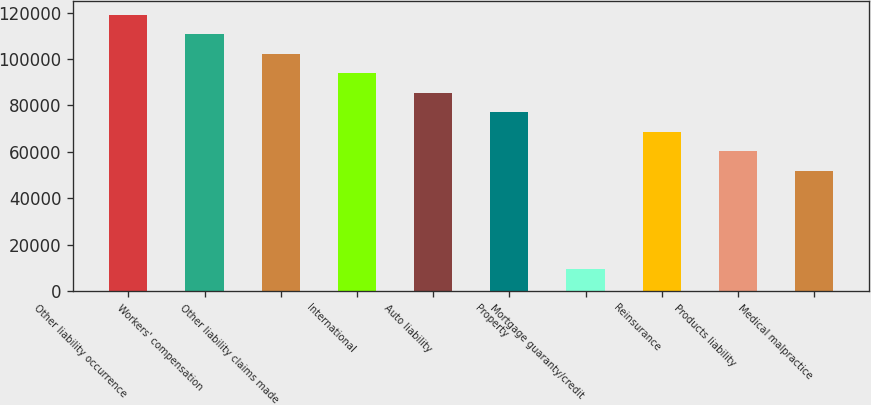Convert chart. <chart><loc_0><loc_0><loc_500><loc_500><bar_chart><fcel>Other liability occurrence<fcel>Workers' compensation<fcel>Other liability claims made<fcel>International<fcel>Auto liability<fcel>Property<fcel>Mortgage guaranty/credit<fcel>Reinsurance<fcel>Products liability<fcel>Medical malpractice<nl><fcel>119211<fcel>110783<fcel>102356<fcel>93927.8<fcel>85500<fcel>77072.2<fcel>9649.8<fcel>68644.4<fcel>60216.6<fcel>51788.8<nl></chart> 